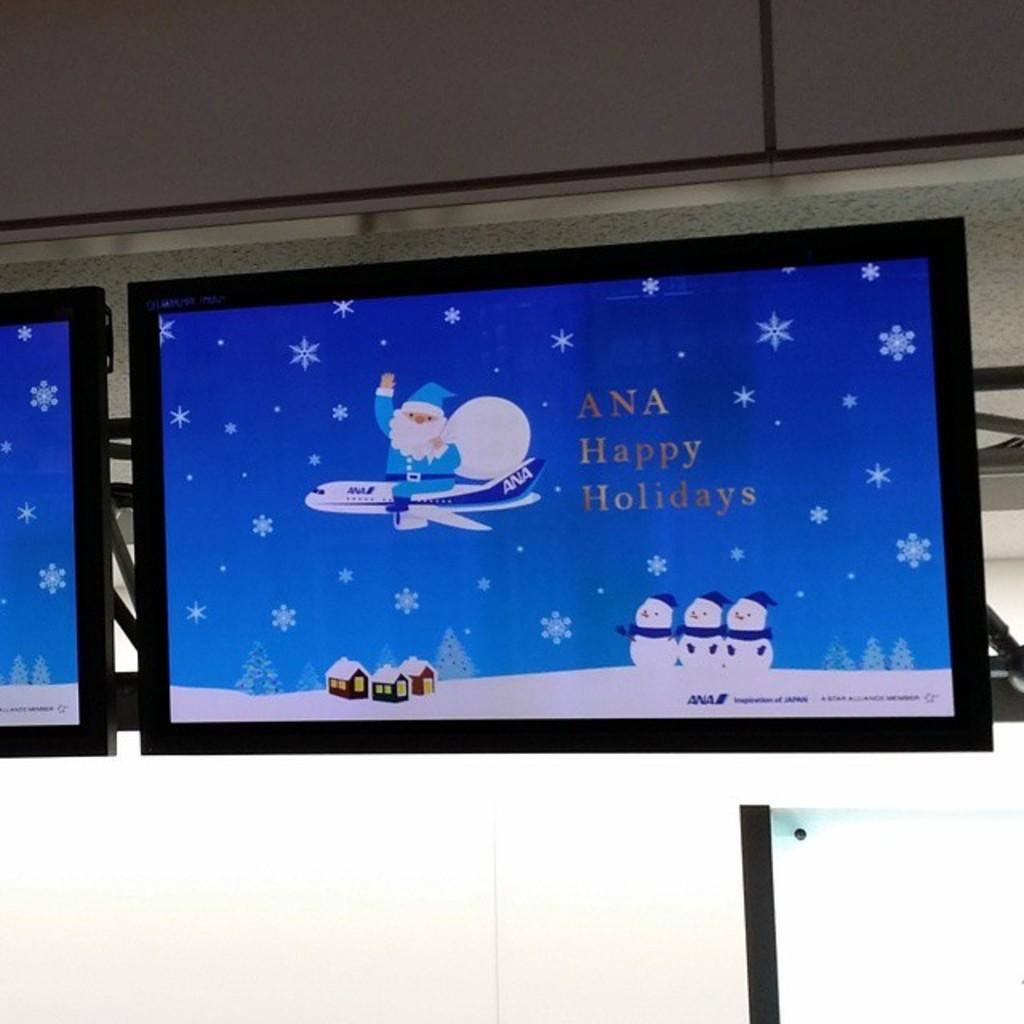Provide a one-sentence caption for the provided image. A holidays message to Ana is displayed on a video screen. 